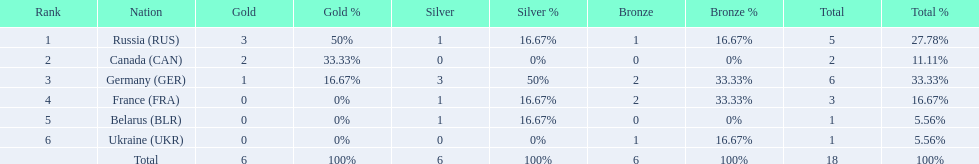Which nations participated? Russia (RUS), Canada (CAN), Germany (GER), France (FRA), Belarus (BLR), Ukraine (UKR). And how many gold medals did they win? 3, 2, 1, 0, 0, 0. What about silver medals? 1, 0, 3, 1, 1, 0. And bronze? 1, 0, 2, 2, 0, 1. Which nation only won gold medals? Canada (CAN). 